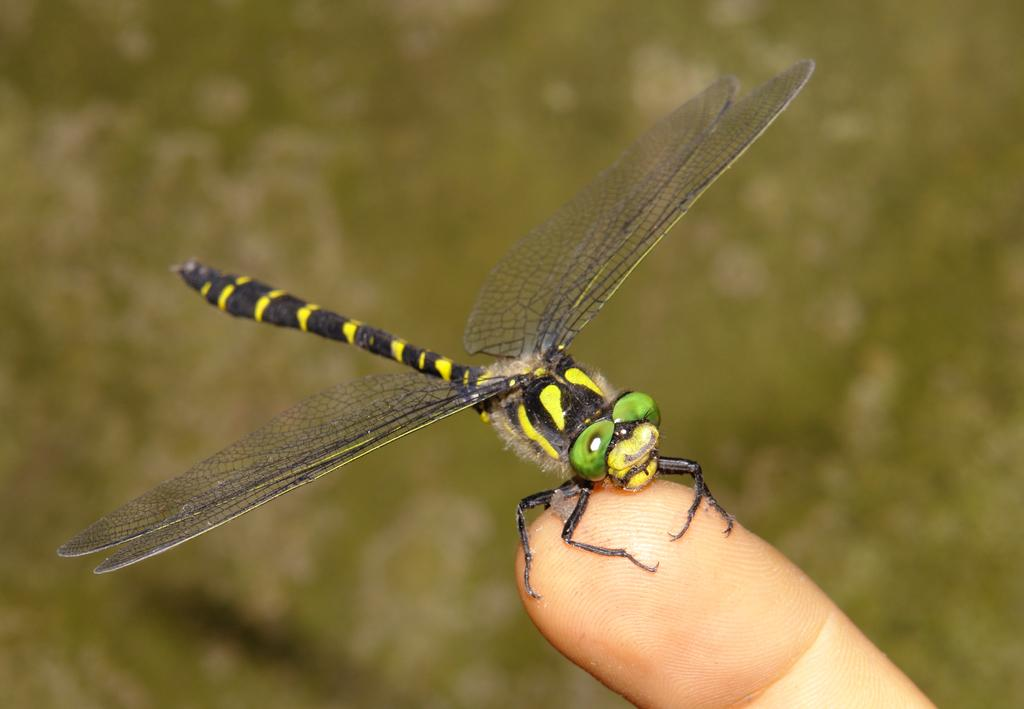What part of a person's body is visible in the image? There is a person's finger in the image. What is on the person's finger in the image? There is an insect on the finger in the image. Can you describe the background of the image? The background of the image is blurry. What advice does the sheep give to the person in the image? There is no sheep present in the image, so it cannot provide any advice. 